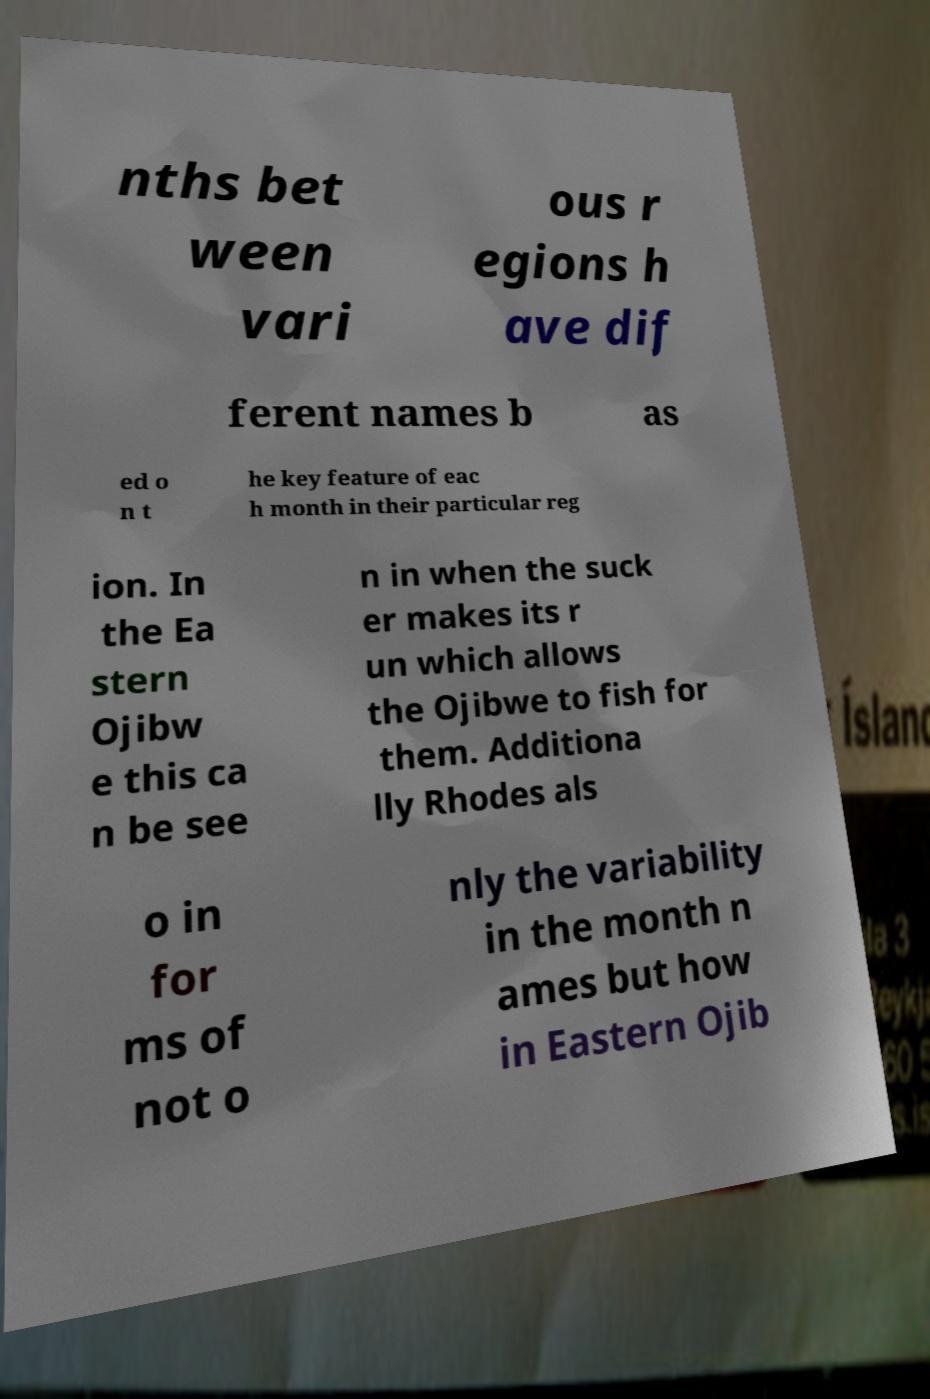Could you assist in decoding the text presented in this image and type it out clearly? nths bet ween vari ous r egions h ave dif ferent names b as ed o n t he key feature of eac h month in their particular reg ion. In the Ea stern Ojibw e this ca n be see n in when the suck er makes its r un which allows the Ojibwe to fish for them. Additiona lly Rhodes als o in for ms of not o nly the variability in the month n ames but how in Eastern Ojib 